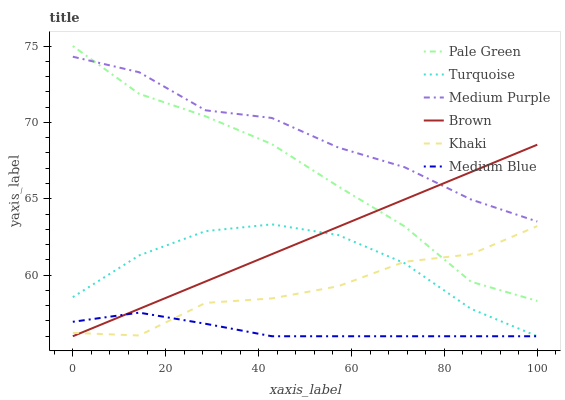Does Turquoise have the minimum area under the curve?
Answer yes or no. No. Does Turquoise have the maximum area under the curve?
Answer yes or no. No. Is Turquoise the smoothest?
Answer yes or no. No. Is Turquoise the roughest?
Answer yes or no. No. Does Khaki have the lowest value?
Answer yes or no. No. Does Turquoise have the highest value?
Answer yes or no. No. Is Medium Blue less than Pale Green?
Answer yes or no. Yes. Is Pale Green greater than Turquoise?
Answer yes or no. Yes. Does Medium Blue intersect Pale Green?
Answer yes or no. No. 